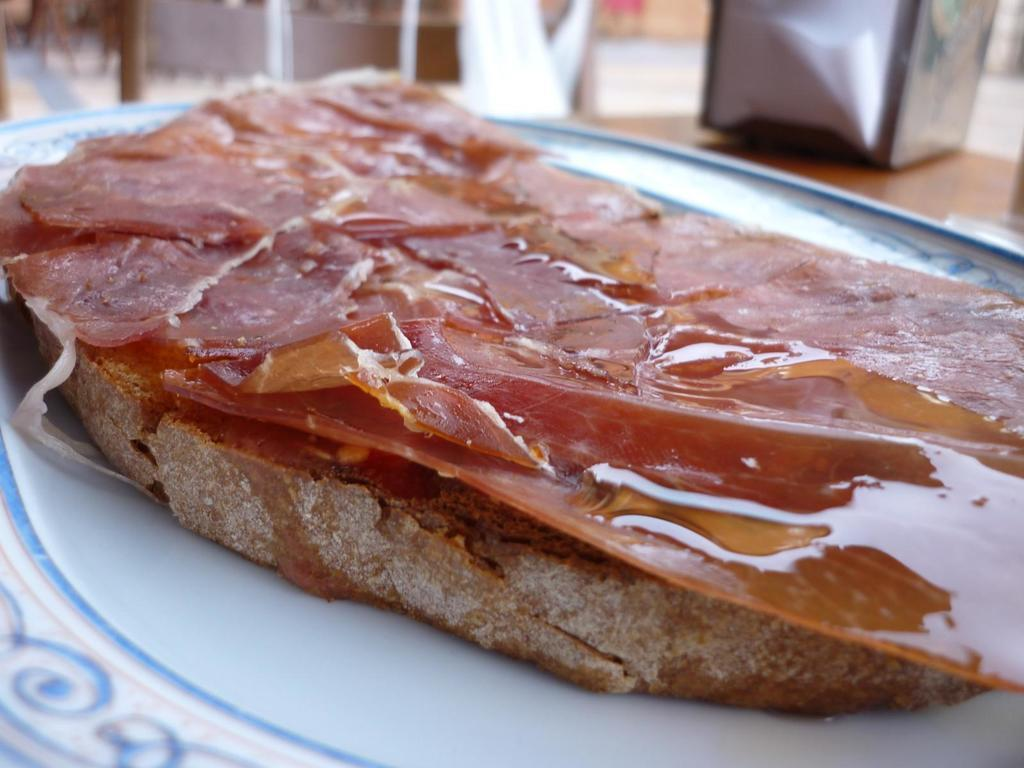What is on the plate that is visible in the image? There is a plate with food in the image. Can you describe the object on the table in the image? Unfortunately, the provided facts do not give enough information to describe the object on the table. What sound can be heard coming from the ring in the image? There is no ring present in the image, so it is not possible to determine what sound might be heard. 